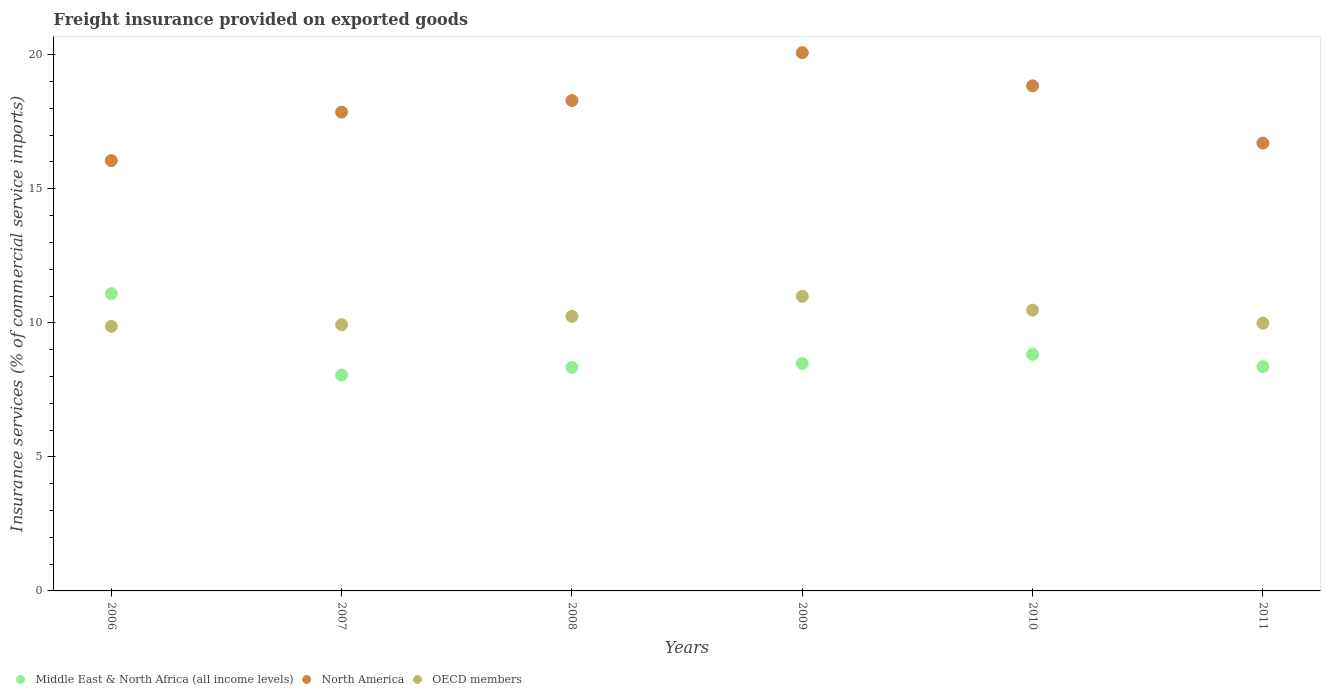What is the freight insurance provided on exported goods in North America in 2009?
Your answer should be very brief. 20.08. Across all years, what is the maximum freight insurance provided on exported goods in Middle East & North Africa (all income levels)?
Provide a succinct answer. 11.09. Across all years, what is the minimum freight insurance provided on exported goods in Middle East & North Africa (all income levels)?
Offer a terse response. 8.05. In which year was the freight insurance provided on exported goods in OECD members maximum?
Provide a succinct answer. 2009. What is the total freight insurance provided on exported goods in North America in the graph?
Ensure brevity in your answer.  107.82. What is the difference between the freight insurance provided on exported goods in Middle East & North Africa (all income levels) in 2007 and that in 2009?
Provide a succinct answer. -0.43. What is the difference between the freight insurance provided on exported goods in Middle East & North Africa (all income levels) in 2009 and the freight insurance provided on exported goods in OECD members in 2007?
Provide a succinct answer. -1.45. What is the average freight insurance provided on exported goods in Middle East & North Africa (all income levels) per year?
Provide a short and direct response. 8.86. In the year 2007, what is the difference between the freight insurance provided on exported goods in North America and freight insurance provided on exported goods in Middle East & North Africa (all income levels)?
Offer a very short reply. 9.81. In how many years, is the freight insurance provided on exported goods in North America greater than 8 %?
Your response must be concise. 6. What is the ratio of the freight insurance provided on exported goods in OECD members in 2008 to that in 2011?
Provide a short and direct response. 1.03. Is the freight insurance provided on exported goods in OECD members in 2006 less than that in 2007?
Give a very brief answer. Yes. What is the difference between the highest and the second highest freight insurance provided on exported goods in North America?
Make the answer very short. 1.24. What is the difference between the highest and the lowest freight insurance provided on exported goods in North America?
Offer a terse response. 4.02. Is the sum of the freight insurance provided on exported goods in North America in 2006 and 2007 greater than the maximum freight insurance provided on exported goods in OECD members across all years?
Offer a very short reply. Yes. Does the freight insurance provided on exported goods in North America monotonically increase over the years?
Provide a succinct answer. No. How many years are there in the graph?
Offer a very short reply. 6. Does the graph contain any zero values?
Provide a succinct answer. No. How are the legend labels stacked?
Provide a succinct answer. Horizontal. What is the title of the graph?
Give a very brief answer. Freight insurance provided on exported goods. Does "Guatemala" appear as one of the legend labels in the graph?
Your answer should be very brief. No. What is the label or title of the Y-axis?
Your answer should be compact. Insurance services (% of commercial service imports). What is the Insurance services (% of commercial service imports) in Middle East & North Africa (all income levels) in 2006?
Keep it short and to the point. 11.09. What is the Insurance services (% of commercial service imports) of North America in 2006?
Ensure brevity in your answer.  16.05. What is the Insurance services (% of commercial service imports) in OECD members in 2006?
Your answer should be compact. 9.87. What is the Insurance services (% of commercial service imports) in Middle East & North Africa (all income levels) in 2007?
Your response must be concise. 8.05. What is the Insurance services (% of commercial service imports) of North America in 2007?
Provide a short and direct response. 17.86. What is the Insurance services (% of commercial service imports) of OECD members in 2007?
Offer a terse response. 9.93. What is the Insurance services (% of commercial service imports) of Middle East & North Africa (all income levels) in 2008?
Make the answer very short. 8.34. What is the Insurance services (% of commercial service imports) in North America in 2008?
Provide a short and direct response. 18.29. What is the Insurance services (% of commercial service imports) of OECD members in 2008?
Make the answer very short. 10.24. What is the Insurance services (% of commercial service imports) of Middle East & North Africa (all income levels) in 2009?
Give a very brief answer. 8.48. What is the Insurance services (% of commercial service imports) in North America in 2009?
Give a very brief answer. 20.08. What is the Insurance services (% of commercial service imports) in OECD members in 2009?
Make the answer very short. 10.99. What is the Insurance services (% of commercial service imports) in Middle East & North Africa (all income levels) in 2010?
Offer a terse response. 8.82. What is the Insurance services (% of commercial service imports) in North America in 2010?
Offer a very short reply. 18.84. What is the Insurance services (% of commercial service imports) of OECD members in 2010?
Provide a short and direct response. 10.47. What is the Insurance services (% of commercial service imports) of Middle East & North Africa (all income levels) in 2011?
Give a very brief answer. 8.36. What is the Insurance services (% of commercial service imports) of North America in 2011?
Your answer should be compact. 16.7. What is the Insurance services (% of commercial service imports) of OECD members in 2011?
Make the answer very short. 9.99. Across all years, what is the maximum Insurance services (% of commercial service imports) of Middle East & North Africa (all income levels)?
Provide a succinct answer. 11.09. Across all years, what is the maximum Insurance services (% of commercial service imports) of North America?
Keep it short and to the point. 20.08. Across all years, what is the maximum Insurance services (% of commercial service imports) of OECD members?
Provide a short and direct response. 10.99. Across all years, what is the minimum Insurance services (% of commercial service imports) in Middle East & North Africa (all income levels)?
Your answer should be compact. 8.05. Across all years, what is the minimum Insurance services (% of commercial service imports) in North America?
Your answer should be very brief. 16.05. Across all years, what is the minimum Insurance services (% of commercial service imports) of OECD members?
Your response must be concise. 9.87. What is the total Insurance services (% of commercial service imports) of Middle East & North Africa (all income levels) in the graph?
Ensure brevity in your answer.  53.14. What is the total Insurance services (% of commercial service imports) in North America in the graph?
Make the answer very short. 107.82. What is the total Insurance services (% of commercial service imports) in OECD members in the graph?
Give a very brief answer. 61.48. What is the difference between the Insurance services (% of commercial service imports) in Middle East & North Africa (all income levels) in 2006 and that in 2007?
Offer a terse response. 3.04. What is the difference between the Insurance services (% of commercial service imports) in North America in 2006 and that in 2007?
Your response must be concise. -1.81. What is the difference between the Insurance services (% of commercial service imports) of OECD members in 2006 and that in 2007?
Provide a short and direct response. -0.06. What is the difference between the Insurance services (% of commercial service imports) of Middle East & North Africa (all income levels) in 2006 and that in 2008?
Make the answer very short. 2.75. What is the difference between the Insurance services (% of commercial service imports) of North America in 2006 and that in 2008?
Make the answer very short. -2.24. What is the difference between the Insurance services (% of commercial service imports) of OECD members in 2006 and that in 2008?
Ensure brevity in your answer.  -0.37. What is the difference between the Insurance services (% of commercial service imports) of Middle East & North Africa (all income levels) in 2006 and that in 2009?
Provide a short and direct response. 2.6. What is the difference between the Insurance services (% of commercial service imports) in North America in 2006 and that in 2009?
Your answer should be compact. -4.02. What is the difference between the Insurance services (% of commercial service imports) in OECD members in 2006 and that in 2009?
Offer a terse response. -1.12. What is the difference between the Insurance services (% of commercial service imports) of Middle East & North Africa (all income levels) in 2006 and that in 2010?
Offer a very short reply. 2.27. What is the difference between the Insurance services (% of commercial service imports) of North America in 2006 and that in 2010?
Offer a very short reply. -2.79. What is the difference between the Insurance services (% of commercial service imports) in OECD members in 2006 and that in 2010?
Provide a short and direct response. -0.6. What is the difference between the Insurance services (% of commercial service imports) in Middle East & North Africa (all income levels) in 2006 and that in 2011?
Offer a very short reply. 2.72. What is the difference between the Insurance services (% of commercial service imports) of North America in 2006 and that in 2011?
Offer a very short reply. -0.65. What is the difference between the Insurance services (% of commercial service imports) of OECD members in 2006 and that in 2011?
Offer a terse response. -0.12. What is the difference between the Insurance services (% of commercial service imports) in Middle East & North Africa (all income levels) in 2007 and that in 2008?
Provide a short and direct response. -0.29. What is the difference between the Insurance services (% of commercial service imports) of North America in 2007 and that in 2008?
Your answer should be compact. -0.43. What is the difference between the Insurance services (% of commercial service imports) in OECD members in 2007 and that in 2008?
Your answer should be very brief. -0.31. What is the difference between the Insurance services (% of commercial service imports) in Middle East & North Africa (all income levels) in 2007 and that in 2009?
Offer a very short reply. -0.43. What is the difference between the Insurance services (% of commercial service imports) in North America in 2007 and that in 2009?
Offer a terse response. -2.22. What is the difference between the Insurance services (% of commercial service imports) in OECD members in 2007 and that in 2009?
Keep it short and to the point. -1.06. What is the difference between the Insurance services (% of commercial service imports) of Middle East & North Africa (all income levels) in 2007 and that in 2010?
Your answer should be compact. -0.77. What is the difference between the Insurance services (% of commercial service imports) in North America in 2007 and that in 2010?
Ensure brevity in your answer.  -0.98. What is the difference between the Insurance services (% of commercial service imports) in OECD members in 2007 and that in 2010?
Give a very brief answer. -0.54. What is the difference between the Insurance services (% of commercial service imports) of Middle East & North Africa (all income levels) in 2007 and that in 2011?
Offer a very short reply. -0.31. What is the difference between the Insurance services (% of commercial service imports) in North America in 2007 and that in 2011?
Ensure brevity in your answer.  1.15. What is the difference between the Insurance services (% of commercial service imports) in OECD members in 2007 and that in 2011?
Make the answer very short. -0.06. What is the difference between the Insurance services (% of commercial service imports) of Middle East & North Africa (all income levels) in 2008 and that in 2009?
Keep it short and to the point. -0.15. What is the difference between the Insurance services (% of commercial service imports) in North America in 2008 and that in 2009?
Offer a terse response. -1.79. What is the difference between the Insurance services (% of commercial service imports) in OECD members in 2008 and that in 2009?
Make the answer very short. -0.75. What is the difference between the Insurance services (% of commercial service imports) of Middle East & North Africa (all income levels) in 2008 and that in 2010?
Provide a short and direct response. -0.48. What is the difference between the Insurance services (% of commercial service imports) in North America in 2008 and that in 2010?
Make the answer very short. -0.55. What is the difference between the Insurance services (% of commercial service imports) in OECD members in 2008 and that in 2010?
Ensure brevity in your answer.  -0.23. What is the difference between the Insurance services (% of commercial service imports) in Middle East & North Africa (all income levels) in 2008 and that in 2011?
Keep it short and to the point. -0.03. What is the difference between the Insurance services (% of commercial service imports) in North America in 2008 and that in 2011?
Give a very brief answer. 1.58. What is the difference between the Insurance services (% of commercial service imports) of OECD members in 2008 and that in 2011?
Your answer should be very brief. 0.25. What is the difference between the Insurance services (% of commercial service imports) in Middle East & North Africa (all income levels) in 2009 and that in 2010?
Your answer should be very brief. -0.34. What is the difference between the Insurance services (% of commercial service imports) in North America in 2009 and that in 2010?
Offer a terse response. 1.24. What is the difference between the Insurance services (% of commercial service imports) in OECD members in 2009 and that in 2010?
Offer a terse response. 0.52. What is the difference between the Insurance services (% of commercial service imports) in Middle East & North Africa (all income levels) in 2009 and that in 2011?
Make the answer very short. 0.12. What is the difference between the Insurance services (% of commercial service imports) of North America in 2009 and that in 2011?
Provide a succinct answer. 3.37. What is the difference between the Insurance services (% of commercial service imports) in OECD members in 2009 and that in 2011?
Provide a succinct answer. 1. What is the difference between the Insurance services (% of commercial service imports) of Middle East & North Africa (all income levels) in 2010 and that in 2011?
Keep it short and to the point. 0.46. What is the difference between the Insurance services (% of commercial service imports) of North America in 2010 and that in 2011?
Make the answer very short. 2.13. What is the difference between the Insurance services (% of commercial service imports) in OECD members in 2010 and that in 2011?
Give a very brief answer. 0.49. What is the difference between the Insurance services (% of commercial service imports) in Middle East & North Africa (all income levels) in 2006 and the Insurance services (% of commercial service imports) in North America in 2007?
Offer a very short reply. -6.77. What is the difference between the Insurance services (% of commercial service imports) in Middle East & North Africa (all income levels) in 2006 and the Insurance services (% of commercial service imports) in OECD members in 2007?
Your response must be concise. 1.16. What is the difference between the Insurance services (% of commercial service imports) in North America in 2006 and the Insurance services (% of commercial service imports) in OECD members in 2007?
Your response must be concise. 6.12. What is the difference between the Insurance services (% of commercial service imports) of Middle East & North Africa (all income levels) in 2006 and the Insurance services (% of commercial service imports) of North America in 2008?
Keep it short and to the point. -7.2. What is the difference between the Insurance services (% of commercial service imports) of Middle East & North Africa (all income levels) in 2006 and the Insurance services (% of commercial service imports) of OECD members in 2008?
Ensure brevity in your answer.  0.85. What is the difference between the Insurance services (% of commercial service imports) of North America in 2006 and the Insurance services (% of commercial service imports) of OECD members in 2008?
Keep it short and to the point. 5.81. What is the difference between the Insurance services (% of commercial service imports) in Middle East & North Africa (all income levels) in 2006 and the Insurance services (% of commercial service imports) in North America in 2009?
Offer a terse response. -8.99. What is the difference between the Insurance services (% of commercial service imports) of Middle East & North Africa (all income levels) in 2006 and the Insurance services (% of commercial service imports) of OECD members in 2009?
Offer a terse response. 0.1. What is the difference between the Insurance services (% of commercial service imports) of North America in 2006 and the Insurance services (% of commercial service imports) of OECD members in 2009?
Your answer should be compact. 5.06. What is the difference between the Insurance services (% of commercial service imports) of Middle East & North Africa (all income levels) in 2006 and the Insurance services (% of commercial service imports) of North America in 2010?
Your answer should be compact. -7.75. What is the difference between the Insurance services (% of commercial service imports) in Middle East & North Africa (all income levels) in 2006 and the Insurance services (% of commercial service imports) in OECD members in 2010?
Provide a short and direct response. 0.61. What is the difference between the Insurance services (% of commercial service imports) in North America in 2006 and the Insurance services (% of commercial service imports) in OECD members in 2010?
Make the answer very short. 5.58. What is the difference between the Insurance services (% of commercial service imports) in Middle East & North Africa (all income levels) in 2006 and the Insurance services (% of commercial service imports) in North America in 2011?
Your response must be concise. -5.62. What is the difference between the Insurance services (% of commercial service imports) in Middle East & North Africa (all income levels) in 2006 and the Insurance services (% of commercial service imports) in OECD members in 2011?
Keep it short and to the point. 1.1. What is the difference between the Insurance services (% of commercial service imports) of North America in 2006 and the Insurance services (% of commercial service imports) of OECD members in 2011?
Keep it short and to the point. 6.07. What is the difference between the Insurance services (% of commercial service imports) in Middle East & North Africa (all income levels) in 2007 and the Insurance services (% of commercial service imports) in North America in 2008?
Make the answer very short. -10.24. What is the difference between the Insurance services (% of commercial service imports) in Middle East & North Africa (all income levels) in 2007 and the Insurance services (% of commercial service imports) in OECD members in 2008?
Ensure brevity in your answer.  -2.19. What is the difference between the Insurance services (% of commercial service imports) of North America in 2007 and the Insurance services (% of commercial service imports) of OECD members in 2008?
Your answer should be compact. 7.62. What is the difference between the Insurance services (% of commercial service imports) in Middle East & North Africa (all income levels) in 2007 and the Insurance services (% of commercial service imports) in North America in 2009?
Your response must be concise. -12.03. What is the difference between the Insurance services (% of commercial service imports) of Middle East & North Africa (all income levels) in 2007 and the Insurance services (% of commercial service imports) of OECD members in 2009?
Ensure brevity in your answer.  -2.94. What is the difference between the Insurance services (% of commercial service imports) of North America in 2007 and the Insurance services (% of commercial service imports) of OECD members in 2009?
Make the answer very short. 6.87. What is the difference between the Insurance services (% of commercial service imports) of Middle East & North Africa (all income levels) in 2007 and the Insurance services (% of commercial service imports) of North America in 2010?
Keep it short and to the point. -10.79. What is the difference between the Insurance services (% of commercial service imports) of Middle East & North Africa (all income levels) in 2007 and the Insurance services (% of commercial service imports) of OECD members in 2010?
Offer a terse response. -2.42. What is the difference between the Insurance services (% of commercial service imports) of North America in 2007 and the Insurance services (% of commercial service imports) of OECD members in 2010?
Ensure brevity in your answer.  7.39. What is the difference between the Insurance services (% of commercial service imports) of Middle East & North Africa (all income levels) in 2007 and the Insurance services (% of commercial service imports) of North America in 2011?
Your answer should be compact. -8.66. What is the difference between the Insurance services (% of commercial service imports) of Middle East & North Africa (all income levels) in 2007 and the Insurance services (% of commercial service imports) of OECD members in 2011?
Your response must be concise. -1.94. What is the difference between the Insurance services (% of commercial service imports) of North America in 2007 and the Insurance services (% of commercial service imports) of OECD members in 2011?
Keep it short and to the point. 7.87. What is the difference between the Insurance services (% of commercial service imports) of Middle East & North Africa (all income levels) in 2008 and the Insurance services (% of commercial service imports) of North America in 2009?
Your answer should be very brief. -11.74. What is the difference between the Insurance services (% of commercial service imports) in Middle East & North Africa (all income levels) in 2008 and the Insurance services (% of commercial service imports) in OECD members in 2009?
Make the answer very short. -2.65. What is the difference between the Insurance services (% of commercial service imports) in North America in 2008 and the Insurance services (% of commercial service imports) in OECD members in 2009?
Provide a succinct answer. 7.3. What is the difference between the Insurance services (% of commercial service imports) of Middle East & North Africa (all income levels) in 2008 and the Insurance services (% of commercial service imports) of North America in 2010?
Your answer should be very brief. -10.5. What is the difference between the Insurance services (% of commercial service imports) in Middle East & North Africa (all income levels) in 2008 and the Insurance services (% of commercial service imports) in OECD members in 2010?
Your response must be concise. -2.14. What is the difference between the Insurance services (% of commercial service imports) in North America in 2008 and the Insurance services (% of commercial service imports) in OECD members in 2010?
Ensure brevity in your answer.  7.82. What is the difference between the Insurance services (% of commercial service imports) of Middle East & North Africa (all income levels) in 2008 and the Insurance services (% of commercial service imports) of North America in 2011?
Ensure brevity in your answer.  -8.37. What is the difference between the Insurance services (% of commercial service imports) in Middle East & North Africa (all income levels) in 2008 and the Insurance services (% of commercial service imports) in OECD members in 2011?
Give a very brief answer. -1.65. What is the difference between the Insurance services (% of commercial service imports) in North America in 2008 and the Insurance services (% of commercial service imports) in OECD members in 2011?
Your answer should be very brief. 8.3. What is the difference between the Insurance services (% of commercial service imports) of Middle East & North Africa (all income levels) in 2009 and the Insurance services (% of commercial service imports) of North America in 2010?
Provide a succinct answer. -10.36. What is the difference between the Insurance services (% of commercial service imports) in Middle East & North Africa (all income levels) in 2009 and the Insurance services (% of commercial service imports) in OECD members in 2010?
Ensure brevity in your answer.  -1.99. What is the difference between the Insurance services (% of commercial service imports) in North America in 2009 and the Insurance services (% of commercial service imports) in OECD members in 2010?
Provide a succinct answer. 9.6. What is the difference between the Insurance services (% of commercial service imports) of Middle East & North Africa (all income levels) in 2009 and the Insurance services (% of commercial service imports) of North America in 2011?
Give a very brief answer. -8.22. What is the difference between the Insurance services (% of commercial service imports) of Middle East & North Africa (all income levels) in 2009 and the Insurance services (% of commercial service imports) of OECD members in 2011?
Give a very brief answer. -1.5. What is the difference between the Insurance services (% of commercial service imports) of North America in 2009 and the Insurance services (% of commercial service imports) of OECD members in 2011?
Ensure brevity in your answer.  10.09. What is the difference between the Insurance services (% of commercial service imports) in Middle East & North Africa (all income levels) in 2010 and the Insurance services (% of commercial service imports) in North America in 2011?
Give a very brief answer. -7.88. What is the difference between the Insurance services (% of commercial service imports) in Middle East & North Africa (all income levels) in 2010 and the Insurance services (% of commercial service imports) in OECD members in 2011?
Keep it short and to the point. -1.17. What is the difference between the Insurance services (% of commercial service imports) of North America in 2010 and the Insurance services (% of commercial service imports) of OECD members in 2011?
Your answer should be compact. 8.85. What is the average Insurance services (% of commercial service imports) of Middle East & North Africa (all income levels) per year?
Ensure brevity in your answer.  8.86. What is the average Insurance services (% of commercial service imports) of North America per year?
Your answer should be very brief. 17.97. What is the average Insurance services (% of commercial service imports) of OECD members per year?
Make the answer very short. 10.25. In the year 2006, what is the difference between the Insurance services (% of commercial service imports) in Middle East & North Africa (all income levels) and Insurance services (% of commercial service imports) in North America?
Keep it short and to the point. -4.97. In the year 2006, what is the difference between the Insurance services (% of commercial service imports) of Middle East & North Africa (all income levels) and Insurance services (% of commercial service imports) of OECD members?
Provide a short and direct response. 1.22. In the year 2006, what is the difference between the Insurance services (% of commercial service imports) of North America and Insurance services (% of commercial service imports) of OECD members?
Provide a succinct answer. 6.18. In the year 2007, what is the difference between the Insurance services (% of commercial service imports) in Middle East & North Africa (all income levels) and Insurance services (% of commercial service imports) in North America?
Make the answer very short. -9.81. In the year 2007, what is the difference between the Insurance services (% of commercial service imports) in Middle East & North Africa (all income levels) and Insurance services (% of commercial service imports) in OECD members?
Offer a terse response. -1.88. In the year 2007, what is the difference between the Insurance services (% of commercial service imports) of North America and Insurance services (% of commercial service imports) of OECD members?
Your answer should be compact. 7.93. In the year 2008, what is the difference between the Insurance services (% of commercial service imports) in Middle East & North Africa (all income levels) and Insurance services (% of commercial service imports) in North America?
Ensure brevity in your answer.  -9.95. In the year 2008, what is the difference between the Insurance services (% of commercial service imports) in Middle East & North Africa (all income levels) and Insurance services (% of commercial service imports) in OECD members?
Give a very brief answer. -1.9. In the year 2008, what is the difference between the Insurance services (% of commercial service imports) of North America and Insurance services (% of commercial service imports) of OECD members?
Make the answer very short. 8.05. In the year 2009, what is the difference between the Insurance services (% of commercial service imports) in Middle East & North Africa (all income levels) and Insurance services (% of commercial service imports) in North America?
Make the answer very short. -11.59. In the year 2009, what is the difference between the Insurance services (% of commercial service imports) in Middle East & North Africa (all income levels) and Insurance services (% of commercial service imports) in OECD members?
Offer a very short reply. -2.51. In the year 2009, what is the difference between the Insurance services (% of commercial service imports) in North America and Insurance services (% of commercial service imports) in OECD members?
Provide a succinct answer. 9.09. In the year 2010, what is the difference between the Insurance services (% of commercial service imports) in Middle East & North Africa (all income levels) and Insurance services (% of commercial service imports) in North America?
Offer a very short reply. -10.02. In the year 2010, what is the difference between the Insurance services (% of commercial service imports) in Middle East & North Africa (all income levels) and Insurance services (% of commercial service imports) in OECD members?
Offer a terse response. -1.65. In the year 2010, what is the difference between the Insurance services (% of commercial service imports) in North America and Insurance services (% of commercial service imports) in OECD members?
Give a very brief answer. 8.37. In the year 2011, what is the difference between the Insurance services (% of commercial service imports) in Middle East & North Africa (all income levels) and Insurance services (% of commercial service imports) in North America?
Your response must be concise. -8.34. In the year 2011, what is the difference between the Insurance services (% of commercial service imports) of Middle East & North Africa (all income levels) and Insurance services (% of commercial service imports) of OECD members?
Provide a short and direct response. -1.62. In the year 2011, what is the difference between the Insurance services (% of commercial service imports) of North America and Insurance services (% of commercial service imports) of OECD members?
Offer a very short reply. 6.72. What is the ratio of the Insurance services (% of commercial service imports) in Middle East & North Africa (all income levels) in 2006 to that in 2007?
Make the answer very short. 1.38. What is the ratio of the Insurance services (% of commercial service imports) of North America in 2006 to that in 2007?
Your answer should be very brief. 0.9. What is the ratio of the Insurance services (% of commercial service imports) in Middle East & North Africa (all income levels) in 2006 to that in 2008?
Your answer should be compact. 1.33. What is the ratio of the Insurance services (% of commercial service imports) of North America in 2006 to that in 2008?
Offer a very short reply. 0.88. What is the ratio of the Insurance services (% of commercial service imports) of OECD members in 2006 to that in 2008?
Offer a terse response. 0.96. What is the ratio of the Insurance services (% of commercial service imports) of Middle East & North Africa (all income levels) in 2006 to that in 2009?
Offer a very short reply. 1.31. What is the ratio of the Insurance services (% of commercial service imports) in North America in 2006 to that in 2009?
Your answer should be compact. 0.8. What is the ratio of the Insurance services (% of commercial service imports) in OECD members in 2006 to that in 2009?
Your answer should be compact. 0.9. What is the ratio of the Insurance services (% of commercial service imports) in Middle East & North Africa (all income levels) in 2006 to that in 2010?
Make the answer very short. 1.26. What is the ratio of the Insurance services (% of commercial service imports) in North America in 2006 to that in 2010?
Your response must be concise. 0.85. What is the ratio of the Insurance services (% of commercial service imports) of OECD members in 2006 to that in 2010?
Offer a terse response. 0.94. What is the ratio of the Insurance services (% of commercial service imports) of Middle East & North Africa (all income levels) in 2006 to that in 2011?
Your response must be concise. 1.33. What is the ratio of the Insurance services (% of commercial service imports) of North America in 2006 to that in 2011?
Offer a terse response. 0.96. What is the ratio of the Insurance services (% of commercial service imports) in OECD members in 2006 to that in 2011?
Ensure brevity in your answer.  0.99. What is the ratio of the Insurance services (% of commercial service imports) of Middle East & North Africa (all income levels) in 2007 to that in 2008?
Provide a short and direct response. 0.97. What is the ratio of the Insurance services (% of commercial service imports) of North America in 2007 to that in 2008?
Make the answer very short. 0.98. What is the ratio of the Insurance services (% of commercial service imports) of OECD members in 2007 to that in 2008?
Provide a succinct answer. 0.97. What is the ratio of the Insurance services (% of commercial service imports) in Middle East & North Africa (all income levels) in 2007 to that in 2009?
Make the answer very short. 0.95. What is the ratio of the Insurance services (% of commercial service imports) in North America in 2007 to that in 2009?
Offer a very short reply. 0.89. What is the ratio of the Insurance services (% of commercial service imports) of OECD members in 2007 to that in 2009?
Your response must be concise. 0.9. What is the ratio of the Insurance services (% of commercial service imports) in Middle East & North Africa (all income levels) in 2007 to that in 2010?
Offer a very short reply. 0.91. What is the ratio of the Insurance services (% of commercial service imports) in North America in 2007 to that in 2010?
Provide a succinct answer. 0.95. What is the ratio of the Insurance services (% of commercial service imports) in OECD members in 2007 to that in 2010?
Provide a succinct answer. 0.95. What is the ratio of the Insurance services (% of commercial service imports) of Middle East & North Africa (all income levels) in 2007 to that in 2011?
Provide a short and direct response. 0.96. What is the ratio of the Insurance services (% of commercial service imports) of North America in 2007 to that in 2011?
Offer a very short reply. 1.07. What is the ratio of the Insurance services (% of commercial service imports) of OECD members in 2007 to that in 2011?
Your answer should be compact. 0.99. What is the ratio of the Insurance services (% of commercial service imports) of Middle East & North Africa (all income levels) in 2008 to that in 2009?
Provide a short and direct response. 0.98. What is the ratio of the Insurance services (% of commercial service imports) of North America in 2008 to that in 2009?
Provide a succinct answer. 0.91. What is the ratio of the Insurance services (% of commercial service imports) in OECD members in 2008 to that in 2009?
Provide a short and direct response. 0.93. What is the ratio of the Insurance services (% of commercial service imports) in Middle East & North Africa (all income levels) in 2008 to that in 2010?
Your answer should be very brief. 0.95. What is the ratio of the Insurance services (% of commercial service imports) in North America in 2008 to that in 2010?
Give a very brief answer. 0.97. What is the ratio of the Insurance services (% of commercial service imports) in OECD members in 2008 to that in 2010?
Give a very brief answer. 0.98. What is the ratio of the Insurance services (% of commercial service imports) in Middle East & North Africa (all income levels) in 2008 to that in 2011?
Give a very brief answer. 1. What is the ratio of the Insurance services (% of commercial service imports) in North America in 2008 to that in 2011?
Give a very brief answer. 1.09. What is the ratio of the Insurance services (% of commercial service imports) of OECD members in 2008 to that in 2011?
Give a very brief answer. 1.03. What is the ratio of the Insurance services (% of commercial service imports) of Middle East & North Africa (all income levels) in 2009 to that in 2010?
Make the answer very short. 0.96. What is the ratio of the Insurance services (% of commercial service imports) of North America in 2009 to that in 2010?
Provide a succinct answer. 1.07. What is the ratio of the Insurance services (% of commercial service imports) in OECD members in 2009 to that in 2010?
Make the answer very short. 1.05. What is the ratio of the Insurance services (% of commercial service imports) of Middle East & North Africa (all income levels) in 2009 to that in 2011?
Give a very brief answer. 1.01. What is the ratio of the Insurance services (% of commercial service imports) of North America in 2009 to that in 2011?
Keep it short and to the point. 1.2. What is the ratio of the Insurance services (% of commercial service imports) in OECD members in 2009 to that in 2011?
Your response must be concise. 1.1. What is the ratio of the Insurance services (% of commercial service imports) in Middle East & North Africa (all income levels) in 2010 to that in 2011?
Offer a terse response. 1.05. What is the ratio of the Insurance services (% of commercial service imports) of North America in 2010 to that in 2011?
Keep it short and to the point. 1.13. What is the ratio of the Insurance services (% of commercial service imports) of OECD members in 2010 to that in 2011?
Your response must be concise. 1.05. What is the difference between the highest and the second highest Insurance services (% of commercial service imports) of Middle East & North Africa (all income levels)?
Provide a succinct answer. 2.27. What is the difference between the highest and the second highest Insurance services (% of commercial service imports) in North America?
Ensure brevity in your answer.  1.24. What is the difference between the highest and the second highest Insurance services (% of commercial service imports) in OECD members?
Make the answer very short. 0.52. What is the difference between the highest and the lowest Insurance services (% of commercial service imports) in Middle East & North Africa (all income levels)?
Give a very brief answer. 3.04. What is the difference between the highest and the lowest Insurance services (% of commercial service imports) in North America?
Keep it short and to the point. 4.02. What is the difference between the highest and the lowest Insurance services (% of commercial service imports) of OECD members?
Provide a short and direct response. 1.12. 